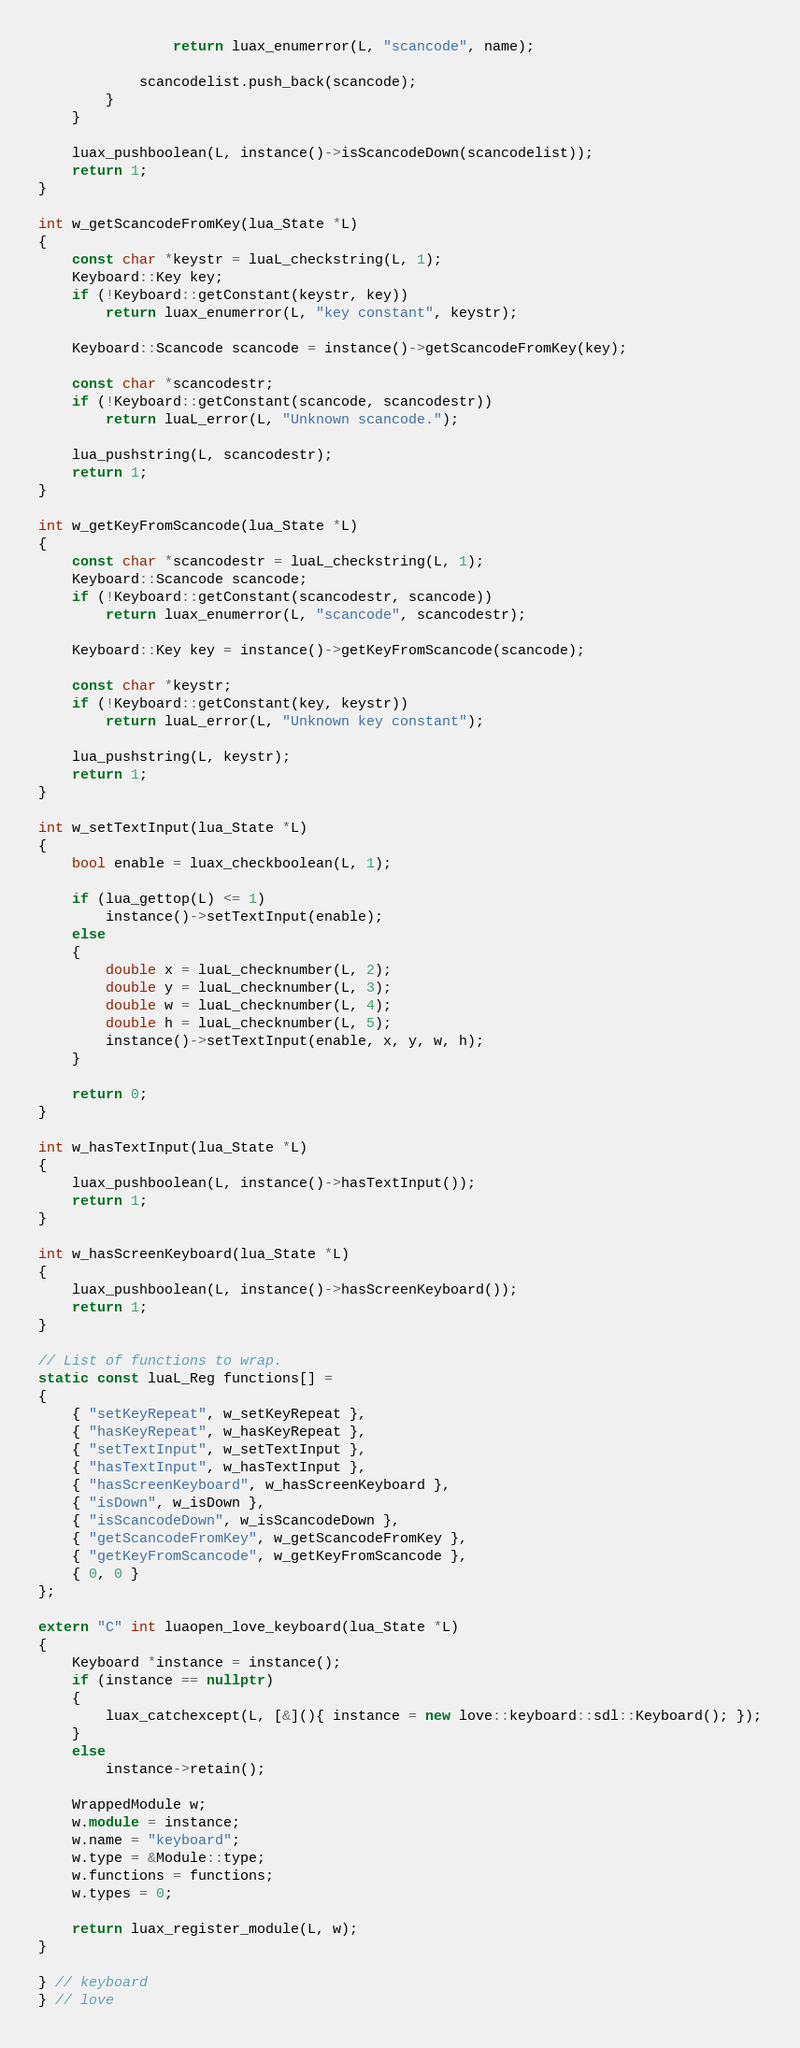<code> <loc_0><loc_0><loc_500><loc_500><_C++_>				return luax_enumerror(L, "scancode", name);

			scancodelist.push_back(scancode);
		}
	}

	luax_pushboolean(L, instance()->isScancodeDown(scancodelist));
	return 1;
}

int w_getScancodeFromKey(lua_State *L)
{
	const char *keystr = luaL_checkstring(L, 1);
	Keyboard::Key key;
	if (!Keyboard::getConstant(keystr, key))
		return luax_enumerror(L, "key constant", keystr);

	Keyboard::Scancode scancode = instance()->getScancodeFromKey(key);

	const char *scancodestr;
	if (!Keyboard::getConstant(scancode, scancodestr))
		return luaL_error(L, "Unknown scancode.");

	lua_pushstring(L, scancodestr);
	return 1;
}

int w_getKeyFromScancode(lua_State *L)
{
	const char *scancodestr = luaL_checkstring(L, 1);
	Keyboard::Scancode scancode;
	if (!Keyboard::getConstant(scancodestr, scancode))
		return luax_enumerror(L, "scancode", scancodestr);

	Keyboard::Key key = instance()->getKeyFromScancode(scancode);

	const char *keystr;
	if (!Keyboard::getConstant(key, keystr))
		return luaL_error(L, "Unknown key constant");

	lua_pushstring(L, keystr);
	return 1;
}

int w_setTextInput(lua_State *L)
{
	bool enable = luax_checkboolean(L, 1);

	if (lua_gettop(L) <= 1)
		instance()->setTextInput(enable);
	else
	{
		double x = luaL_checknumber(L, 2);
		double y = luaL_checknumber(L, 3);
		double w = luaL_checknumber(L, 4);
		double h = luaL_checknumber(L, 5);
		instance()->setTextInput(enable, x, y, w, h);
	}

	return 0;
}

int w_hasTextInput(lua_State *L)
{
	luax_pushboolean(L, instance()->hasTextInput());
	return 1;
}

int w_hasScreenKeyboard(lua_State *L)
{
	luax_pushboolean(L, instance()->hasScreenKeyboard());
	return 1;
}

// List of functions to wrap.
static const luaL_Reg functions[] =
{
	{ "setKeyRepeat", w_setKeyRepeat },
	{ "hasKeyRepeat", w_hasKeyRepeat },
	{ "setTextInput", w_setTextInput },
	{ "hasTextInput", w_hasTextInput },
	{ "hasScreenKeyboard", w_hasScreenKeyboard },
	{ "isDown", w_isDown },
	{ "isScancodeDown", w_isScancodeDown },
	{ "getScancodeFromKey", w_getScancodeFromKey },
	{ "getKeyFromScancode", w_getKeyFromScancode },
	{ 0, 0 }
};

extern "C" int luaopen_love_keyboard(lua_State *L)
{
	Keyboard *instance = instance();
	if (instance == nullptr)
	{
		luax_catchexcept(L, [&](){ instance = new love::keyboard::sdl::Keyboard(); });
	}
	else
		instance->retain();

	WrappedModule w;
	w.module = instance;
	w.name = "keyboard";
	w.type = &Module::type;
	w.functions = functions;
	w.types = 0;

	return luax_register_module(L, w);
}

} // keyboard
} // love
</code> 